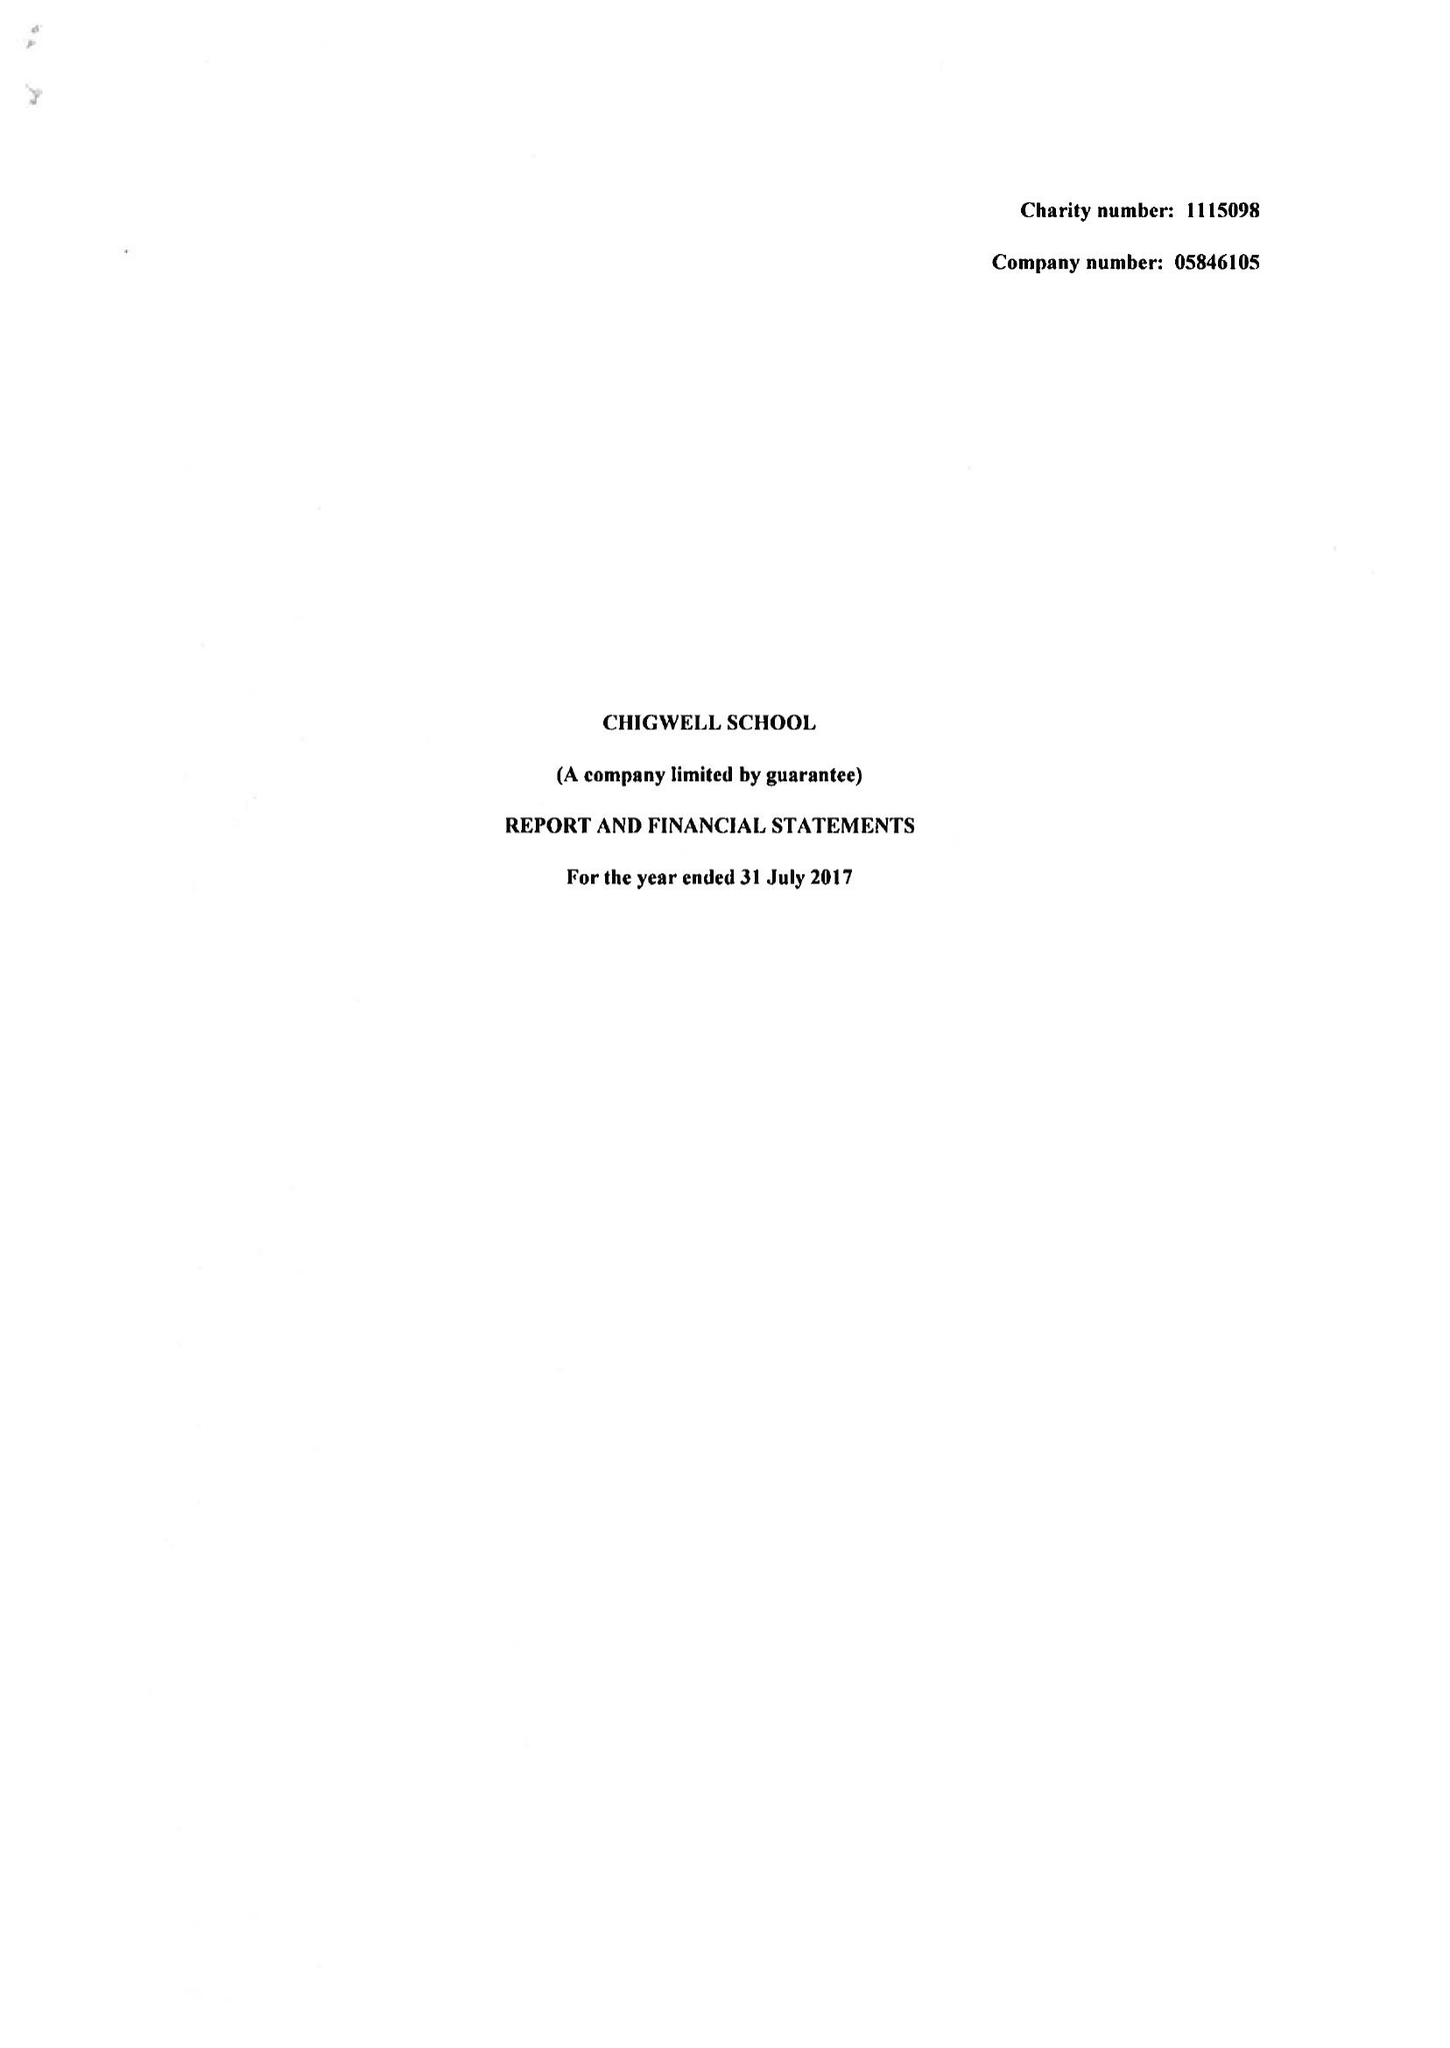What is the value for the address__postcode?
Answer the question using a single word or phrase. IG7 6QF 